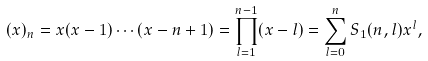Convert formula to latex. <formula><loc_0><loc_0><loc_500><loc_500>( x ) _ { n } = x ( x - 1 ) \cdots ( x - n + 1 ) = \prod _ { l = 1 } ^ { n - 1 } ( x - l ) = \sum _ { l = 0 } ^ { n } S _ { 1 } ( n , l ) x ^ { l } ,</formula> 